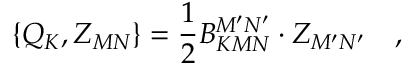Convert formula to latex. <formula><loc_0><loc_0><loc_500><loc_500>\left \{ Q _ { K } , Z _ { M N } \right \} = \frac { 1 } { 2 } B _ { K M N } ^ { M ^ { \prime } N ^ { \prime } } \cdot Z _ { M ^ { \prime } N ^ { \prime } } \quad ,</formula> 